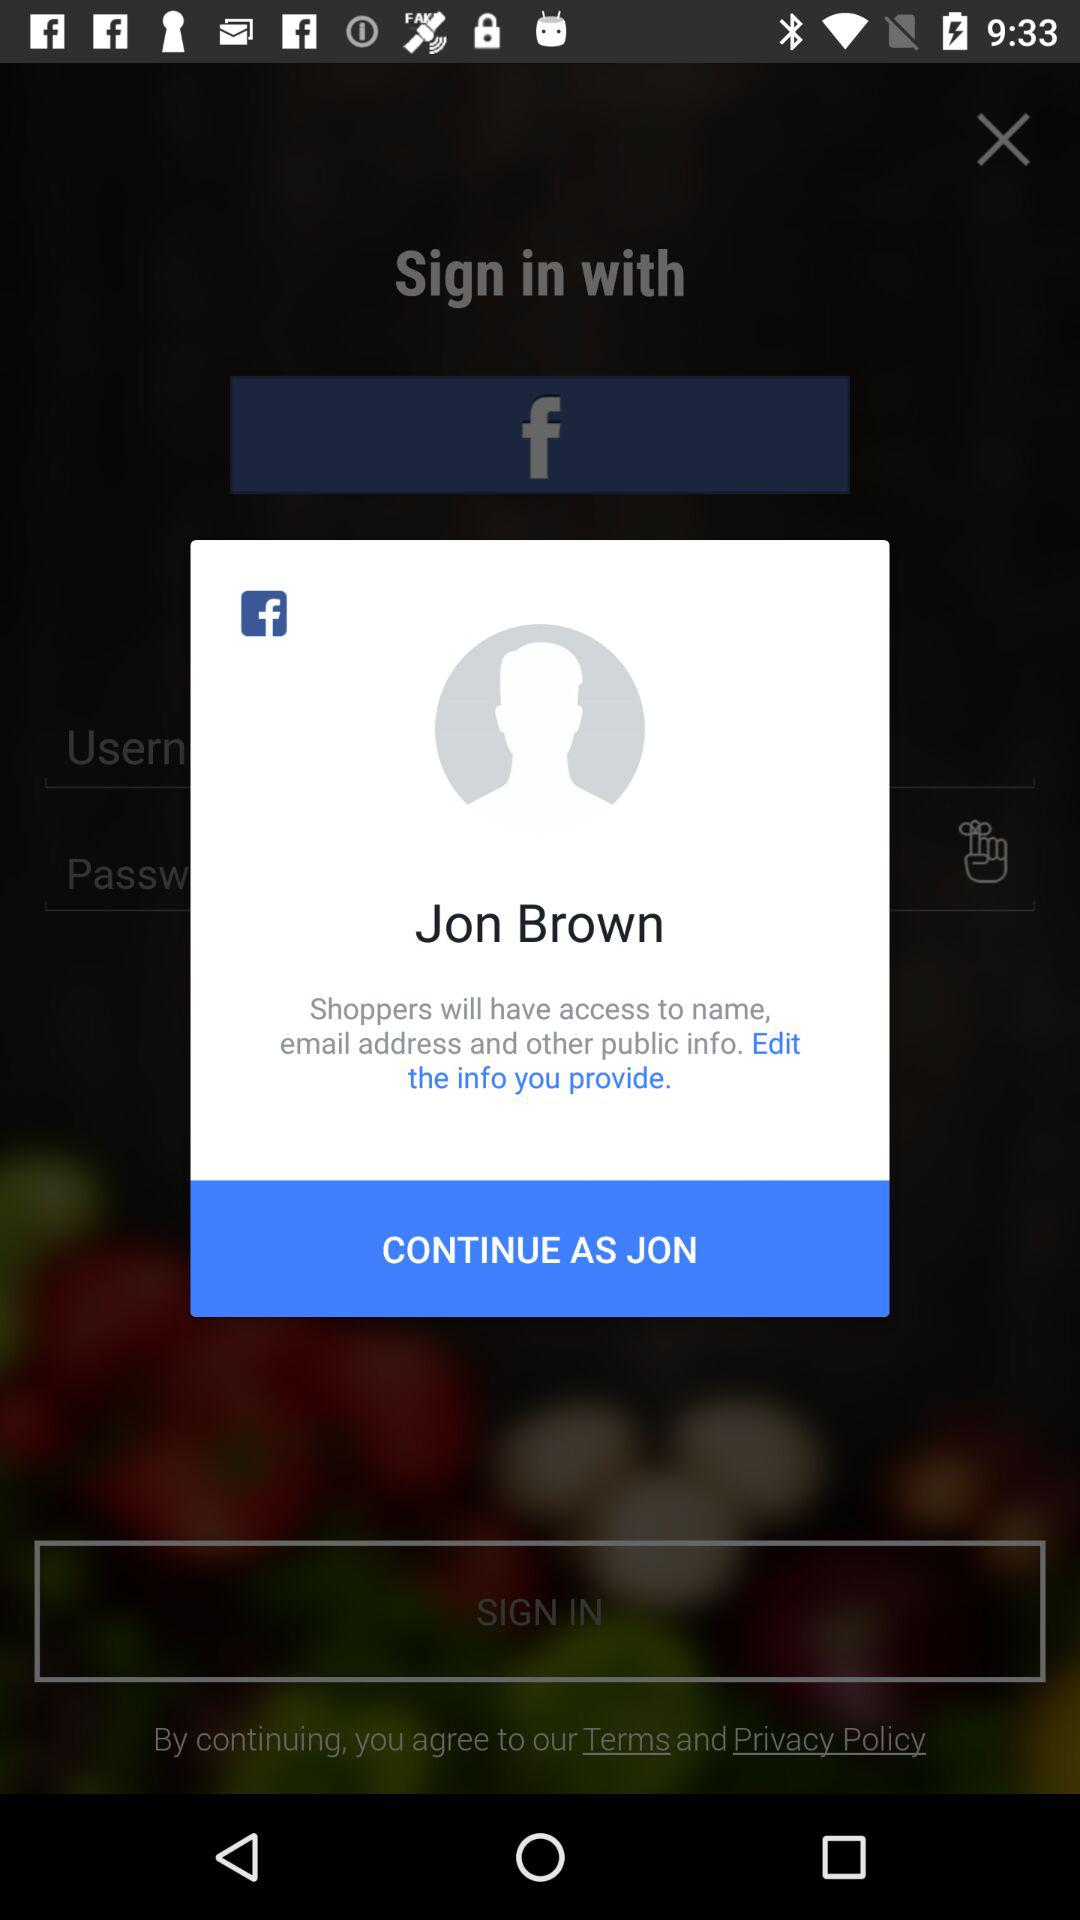What application can we use to sign in? The application that can be used to sign in is "Facebook". 